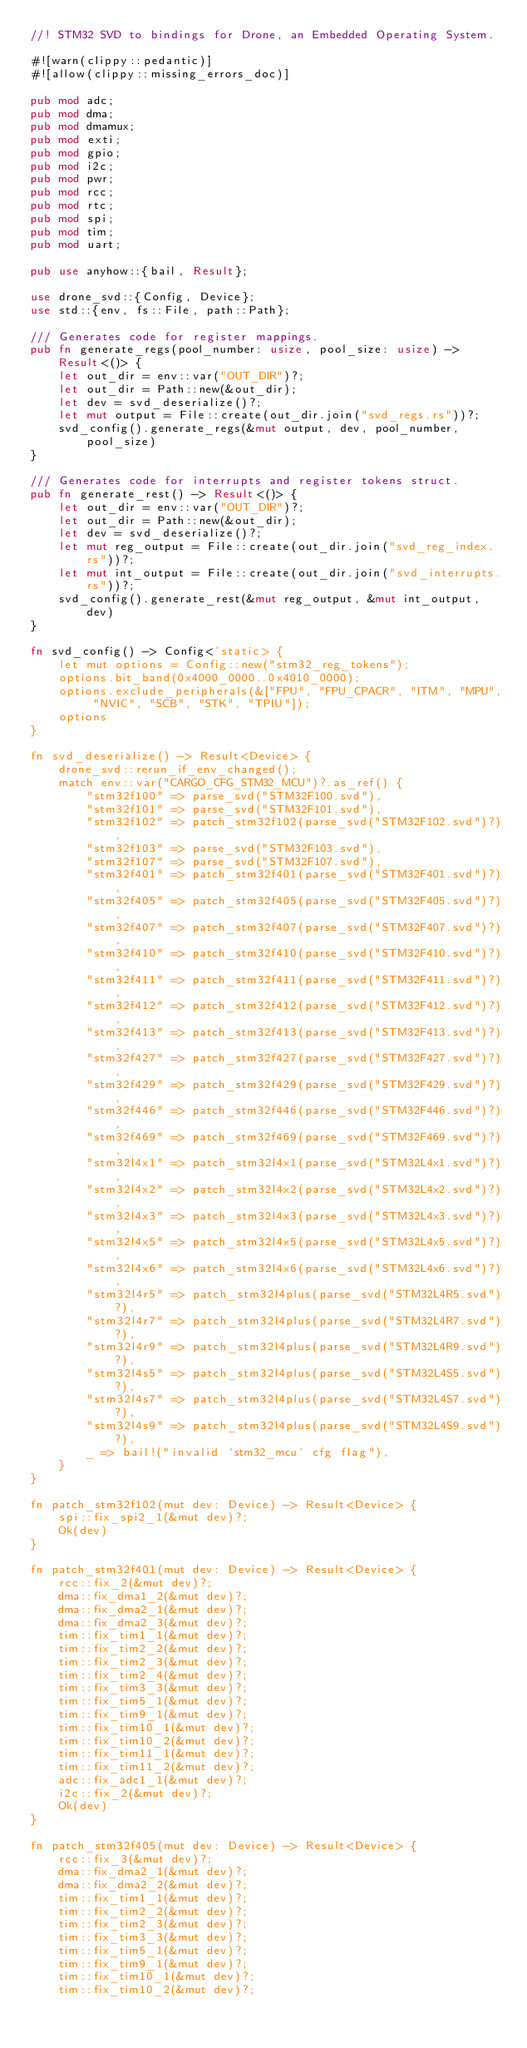Convert code to text. <code><loc_0><loc_0><loc_500><loc_500><_Rust_>//! STM32 SVD to bindings for Drone, an Embedded Operating System.

#![warn(clippy::pedantic)]
#![allow(clippy::missing_errors_doc)]

pub mod adc;
pub mod dma;
pub mod dmamux;
pub mod exti;
pub mod gpio;
pub mod i2c;
pub mod pwr;
pub mod rcc;
pub mod rtc;
pub mod spi;
pub mod tim;
pub mod uart;

pub use anyhow::{bail, Result};

use drone_svd::{Config, Device};
use std::{env, fs::File, path::Path};

/// Generates code for register mappings.
pub fn generate_regs(pool_number: usize, pool_size: usize) -> Result<()> {
    let out_dir = env::var("OUT_DIR")?;
    let out_dir = Path::new(&out_dir);
    let dev = svd_deserialize()?;
    let mut output = File::create(out_dir.join("svd_regs.rs"))?;
    svd_config().generate_regs(&mut output, dev, pool_number, pool_size)
}

/// Generates code for interrupts and register tokens struct.
pub fn generate_rest() -> Result<()> {
    let out_dir = env::var("OUT_DIR")?;
    let out_dir = Path::new(&out_dir);
    let dev = svd_deserialize()?;
    let mut reg_output = File::create(out_dir.join("svd_reg_index.rs"))?;
    let mut int_output = File::create(out_dir.join("svd_interrupts.rs"))?;
    svd_config().generate_rest(&mut reg_output, &mut int_output, dev)
}

fn svd_config() -> Config<'static> {
    let mut options = Config::new("stm32_reg_tokens");
    options.bit_band(0x4000_0000..0x4010_0000);
    options.exclude_peripherals(&["FPU", "FPU_CPACR", "ITM", "MPU", "NVIC", "SCB", "STK", "TPIU"]);
    options
}

fn svd_deserialize() -> Result<Device> {
    drone_svd::rerun_if_env_changed();
    match env::var("CARGO_CFG_STM32_MCU")?.as_ref() {
        "stm32f100" => parse_svd("STM32F100.svd"),
        "stm32f101" => parse_svd("STM32F101.svd"),
        "stm32f102" => patch_stm32f102(parse_svd("STM32F102.svd")?),
        "stm32f103" => parse_svd("STM32F103.svd"),
        "stm32f107" => parse_svd("STM32F107.svd"),
        "stm32f401" => patch_stm32f401(parse_svd("STM32F401.svd")?),
        "stm32f405" => patch_stm32f405(parse_svd("STM32F405.svd")?),
        "stm32f407" => patch_stm32f407(parse_svd("STM32F407.svd")?),
        "stm32f410" => patch_stm32f410(parse_svd("STM32F410.svd")?),
        "stm32f411" => patch_stm32f411(parse_svd("STM32F411.svd")?),
        "stm32f412" => patch_stm32f412(parse_svd("STM32F412.svd")?),
        "stm32f413" => patch_stm32f413(parse_svd("STM32F413.svd")?),
        "stm32f427" => patch_stm32f427(parse_svd("STM32F427.svd")?),
        "stm32f429" => patch_stm32f429(parse_svd("STM32F429.svd")?),
        "stm32f446" => patch_stm32f446(parse_svd("STM32F446.svd")?),
        "stm32f469" => patch_stm32f469(parse_svd("STM32F469.svd")?),
        "stm32l4x1" => patch_stm32l4x1(parse_svd("STM32L4x1.svd")?),
        "stm32l4x2" => patch_stm32l4x2(parse_svd("STM32L4x2.svd")?),
        "stm32l4x3" => patch_stm32l4x3(parse_svd("STM32L4x3.svd")?),
        "stm32l4x5" => patch_stm32l4x5(parse_svd("STM32L4x5.svd")?),
        "stm32l4x6" => patch_stm32l4x6(parse_svd("STM32L4x6.svd")?),
        "stm32l4r5" => patch_stm32l4plus(parse_svd("STM32L4R5.svd")?),
        "stm32l4r7" => patch_stm32l4plus(parse_svd("STM32L4R7.svd")?),
        "stm32l4r9" => patch_stm32l4plus(parse_svd("STM32L4R9.svd")?),
        "stm32l4s5" => patch_stm32l4plus(parse_svd("STM32L4S5.svd")?),
        "stm32l4s7" => patch_stm32l4plus(parse_svd("STM32L4S7.svd")?),
        "stm32l4s9" => patch_stm32l4plus(parse_svd("STM32L4S9.svd")?),
        _ => bail!("invalid `stm32_mcu` cfg flag"),
    }
}

fn patch_stm32f102(mut dev: Device) -> Result<Device> {
    spi::fix_spi2_1(&mut dev)?;
    Ok(dev)
}

fn patch_stm32f401(mut dev: Device) -> Result<Device> {
    rcc::fix_2(&mut dev)?;
    dma::fix_dma1_2(&mut dev)?;
    dma::fix_dma2_1(&mut dev)?;
    dma::fix_dma2_3(&mut dev)?;
    tim::fix_tim1_1(&mut dev)?;
    tim::fix_tim2_2(&mut dev)?;
    tim::fix_tim2_3(&mut dev)?;
    tim::fix_tim2_4(&mut dev)?;
    tim::fix_tim3_3(&mut dev)?;
    tim::fix_tim5_1(&mut dev)?;
    tim::fix_tim9_1(&mut dev)?;
    tim::fix_tim10_1(&mut dev)?;
    tim::fix_tim10_2(&mut dev)?;
    tim::fix_tim11_1(&mut dev)?;
    tim::fix_tim11_2(&mut dev)?;
    adc::fix_adc1_1(&mut dev)?;
    i2c::fix_2(&mut dev)?;
    Ok(dev)
}

fn patch_stm32f405(mut dev: Device) -> Result<Device> {
    rcc::fix_3(&mut dev)?;
    dma::fix_dma2_1(&mut dev)?;
    dma::fix_dma2_2(&mut dev)?;
    tim::fix_tim1_1(&mut dev)?;
    tim::fix_tim2_2(&mut dev)?;
    tim::fix_tim2_3(&mut dev)?;
    tim::fix_tim3_3(&mut dev)?;
    tim::fix_tim5_1(&mut dev)?;
    tim::fix_tim9_1(&mut dev)?;
    tim::fix_tim10_1(&mut dev)?;
    tim::fix_tim10_2(&mut dev)?;</code> 